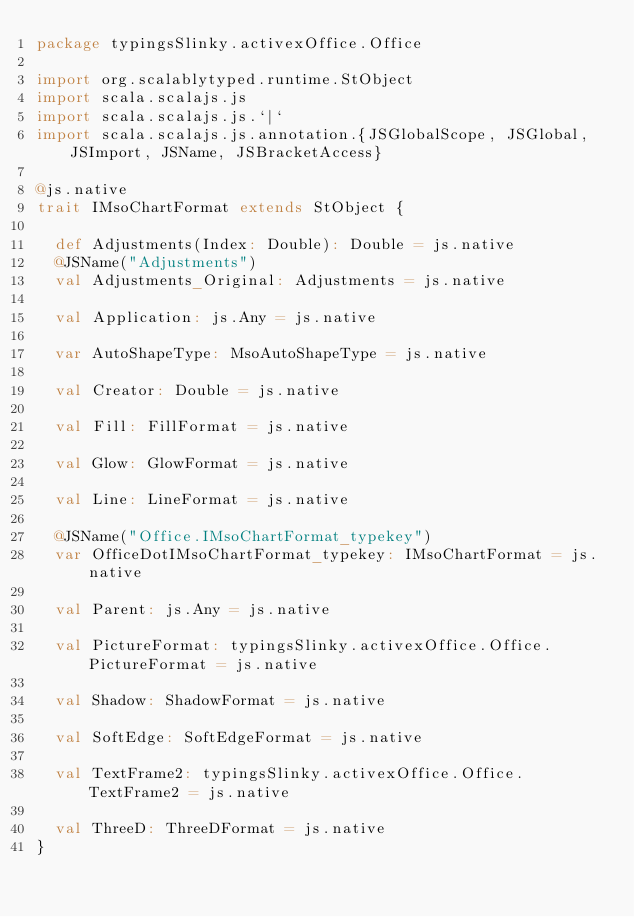<code> <loc_0><loc_0><loc_500><loc_500><_Scala_>package typingsSlinky.activexOffice.Office

import org.scalablytyped.runtime.StObject
import scala.scalajs.js
import scala.scalajs.js.`|`
import scala.scalajs.js.annotation.{JSGlobalScope, JSGlobal, JSImport, JSName, JSBracketAccess}

@js.native
trait IMsoChartFormat extends StObject {
  
  def Adjustments(Index: Double): Double = js.native
  @JSName("Adjustments")
  val Adjustments_Original: Adjustments = js.native
  
  val Application: js.Any = js.native
  
  var AutoShapeType: MsoAutoShapeType = js.native
  
  val Creator: Double = js.native
  
  val Fill: FillFormat = js.native
  
  val Glow: GlowFormat = js.native
  
  val Line: LineFormat = js.native
  
  @JSName("Office.IMsoChartFormat_typekey")
  var OfficeDotIMsoChartFormat_typekey: IMsoChartFormat = js.native
  
  val Parent: js.Any = js.native
  
  val PictureFormat: typingsSlinky.activexOffice.Office.PictureFormat = js.native
  
  val Shadow: ShadowFormat = js.native
  
  val SoftEdge: SoftEdgeFormat = js.native
  
  val TextFrame2: typingsSlinky.activexOffice.Office.TextFrame2 = js.native
  
  val ThreeD: ThreeDFormat = js.native
}
</code> 